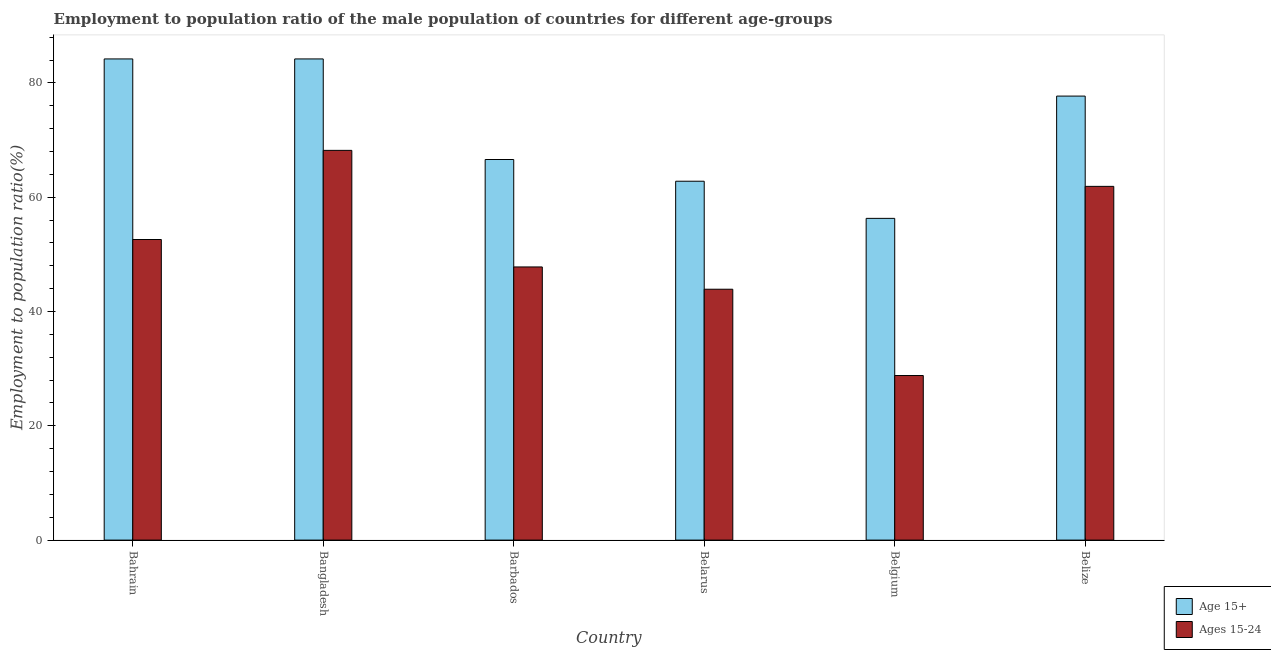How many groups of bars are there?
Give a very brief answer. 6. Are the number of bars on each tick of the X-axis equal?
Provide a succinct answer. Yes. How many bars are there on the 1st tick from the left?
Offer a very short reply. 2. What is the label of the 5th group of bars from the left?
Keep it short and to the point. Belgium. What is the employment to population ratio(age 15-24) in Belarus?
Make the answer very short. 43.9. Across all countries, what is the maximum employment to population ratio(age 15-24)?
Give a very brief answer. 68.2. Across all countries, what is the minimum employment to population ratio(age 15-24)?
Your answer should be compact. 28.8. In which country was the employment to population ratio(age 15+) minimum?
Your answer should be compact. Belgium. What is the total employment to population ratio(age 15+) in the graph?
Offer a terse response. 431.8. What is the difference between the employment to population ratio(age 15-24) in Belgium and that in Belize?
Offer a very short reply. -33.1. What is the difference between the employment to population ratio(age 15+) in Bangladesh and the employment to population ratio(age 15-24) in Belarus?
Offer a very short reply. 40.3. What is the average employment to population ratio(age 15+) per country?
Your answer should be very brief. 71.97. What is the difference between the employment to population ratio(age 15+) and employment to population ratio(age 15-24) in Belgium?
Your answer should be very brief. 27.5. What is the ratio of the employment to population ratio(age 15+) in Belarus to that in Belgium?
Your answer should be compact. 1.12. Is the employment to population ratio(age 15+) in Bangladesh less than that in Belize?
Provide a succinct answer. No. What is the difference between the highest and the second highest employment to population ratio(age 15-24)?
Provide a succinct answer. 6.3. What is the difference between the highest and the lowest employment to population ratio(age 15-24)?
Ensure brevity in your answer.  39.4. In how many countries, is the employment to population ratio(age 15-24) greater than the average employment to population ratio(age 15-24) taken over all countries?
Your answer should be compact. 3. Is the sum of the employment to population ratio(age 15+) in Belgium and Belize greater than the maximum employment to population ratio(age 15-24) across all countries?
Offer a terse response. Yes. What does the 1st bar from the left in Bahrain represents?
Your answer should be compact. Age 15+. What does the 2nd bar from the right in Bangladesh represents?
Provide a short and direct response. Age 15+. Are all the bars in the graph horizontal?
Provide a short and direct response. No. How many countries are there in the graph?
Your answer should be very brief. 6. Are the values on the major ticks of Y-axis written in scientific E-notation?
Make the answer very short. No. Does the graph contain any zero values?
Ensure brevity in your answer.  No. Does the graph contain grids?
Give a very brief answer. No. How many legend labels are there?
Keep it short and to the point. 2. What is the title of the graph?
Provide a succinct answer. Employment to population ratio of the male population of countries for different age-groups. What is the Employment to population ratio(%) in Age 15+ in Bahrain?
Your answer should be compact. 84.2. What is the Employment to population ratio(%) in Ages 15-24 in Bahrain?
Provide a short and direct response. 52.6. What is the Employment to population ratio(%) in Age 15+ in Bangladesh?
Your answer should be very brief. 84.2. What is the Employment to population ratio(%) in Ages 15-24 in Bangladesh?
Provide a short and direct response. 68.2. What is the Employment to population ratio(%) of Age 15+ in Barbados?
Offer a very short reply. 66.6. What is the Employment to population ratio(%) in Ages 15-24 in Barbados?
Your answer should be very brief. 47.8. What is the Employment to population ratio(%) of Age 15+ in Belarus?
Your answer should be compact. 62.8. What is the Employment to population ratio(%) of Ages 15-24 in Belarus?
Ensure brevity in your answer.  43.9. What is the Employment to population ratio(%) of Age 15+ in Belgium?
Offer a very short reply. 56.3. What is the Employment to population ratio(%) in Ages 15-24 in Belgium?
Give a very brief answer. 28.8. What is the Employment to population ratio(%) in Age 15+ in Belize?
Offer a terse response. 77.7. What is the Employment to population ratio(%) in Ages 15-24 in Belize?
Make the answer very short. 61.9. Across all countries, what is the maximum Employment to population ratio(%) of Age 15+?
Provide a succinct answer. 84.2. Across all countries, what is the maximum Employment to population ratio(%) in Ages 15-24?
Provide a succinct answer. 68.2. Across all countries, what is the minimum Employment to population ratio(%) in Age 15+?
Your answer should be compact. 56.3. Across all countries, what is the minimum Employment to population ratio(%) of Ages 15-24?
Your response must be concise. 28.8. What is the total Employment to population ratio(%) in Age 15+ in the graph?
Give a very brief answer. 431.8. What is the total Employment to population ratio(%) in Ages 15-24 in the graph?
Provide a short and direct response. 303.2. What is the difference between the Employment to population ratio(%) in Age 15+ in Bahrain and that in Bangladesh?
Offer a terse response. 0. What is the difference between the Employment to population ratio(%) of Ages 15-24 in Bahrain and that in Bangladesh?
Your response must be concise. -15.6. What is the difference between the Employment to population ratio(%) in Ages 15-24 in Bahrain and that in Barbados?
Give a very brief answer. 4.8. What is the difference between the Employment to population ratio(%) in Age 15+ in Bahrain and that in Belarus?
Your answer should be very brief. 21.4. What is the difference between the Employment to population ratio(%) of Age 15+ in Bahrain and that in Belgium?
Make the answer very short. 27.9. What is the difference between the Employment to population ratio(%) in Ages 15-24 in Bahrain and that in Belgium?
Give a very brief answer. 23.8. What is the difference between the Employment to population ratio(%) of Ages 15-24 in Bahrain and that in Belize?
Offer a terse response. -9.3. What is the difference between the Employment to population ratio(%) in Ages 15-24 in Bangladesh and that in Barbados?
Ensure brevity in your answer.  20.4. What is the difference between the Employment to population ratio(%) of Age 15+ in Bangladesh and that in Belarus?
Provide a succinct answer. 21.4. What is the difference between the Employment to population ratio(%) of Ages 15-24 in Bangladesh and that in Belarus?
Offer a very short reply. 24.3. What is the difference between the Employment to population ratio(%) of Age 15+ in Bangladesh and that in Belgium?
Provide a succinct answer. 27.9. What is the difference between the Employment to population ratio(%) of Ages 15-24 in Bangladesh and that in Belgium?
Provide a short and direct response. 39.4. What is the difference between the Employment to population ratio(%) in Age 15+ in Bangladesh and that in Belize?
Your answer should be very brief. 6.5. What is the difference between the Employment to population ratio(%) of Ages 15-24 in Barbados and that in Belize?
Your answer should be very brief. -14.1. What is the difference between the Employment to population ratio(%) of Age 15+ in Belarus and that in Belgium?
Make the answer very short. 6.5. What is the difference between the Employment to population ratio(%) of Age 15+ in Belarus and that in Belize?
Your answer should be very brief. -14.9. What is the difference between the Employment to population ratio(%) in Ages 15-24 in Belarus and that in Belize?
Keep it short and to the point. -18. What is the difference between the Employment to population ratio(%) of Age 15+ in Belgium and that in Belize?
Offer a very short reply. -21.4. What is the difference between the Employment to population ratio(%) in Ages 15-24 in Belgium and that in Belize?
Provide a short and direct response. -33.1. What is the difference between the Employment to population ratio(%) of Age 15+ in Bahrain and the Employment to population ratio(%) of Ages 15-24 in Bangladesh?
Your answer should be compact. 16. What is the difference between the Employment to population ratio(%) of Age 15+ in Bahrain and the Employment to population ratio(%) of Ages 15-24 in Barbados?
Your response must be concise. 36.4. What is the difference between the Employment to population ratio(%) in Age 15+ in Bahrain and the Employment to population ratio(%) in Ages 15-24 in Belarus?
Offer a very short reply. 40.3. What is the difference between the Employment to population ratio(%) of Age 15+ in Bahrain and the Employment to population ratio(%) of Ages 15-24 in Belgium?
Offer a terse response. 55.4. What is the difference between the Employment to population ratio(%) of Age 15+ in Bahrain and the Employment to population ratio(%) of Ages 15-24 in Belize?
Your response must be concise. 22.3. What is the difference between the Employment to population ratio(%) of Age 15+ in Bangladesh and the Employment to population ratio(%) of Ages 15-24 in Barbados?
Provide a succinct answer. 36.4. What is the difference between the Employment to population ratio(%) in Age 15+ in Bangladesh and the Employment to population ratio(%) in Ages 15-24 in Belarus?
Your response must be concise. 40.3. What is the difference between the Employment to population ratio(%) in Age 15+ in Bangladesh and the Employment to population ratio(%) in Ages 15-24 in Belgium?
Provide a succinct answer. 55.4. What is the difference between the Employment to population ratio(%) in Age 15+ in Bangladesh and the Employment to population ratio(%) in Ages 15-24 in Belize?
Provide a short and direct response. 22.3. What is the difference between the Employment to population ratio(%) of Age 15+ in Barbados and the Employment to population ratio(%) of Ages 15-24 in Belarus?
Offer a terse response. 22.7. What is the difference between the Employment to population ratio(%) of Age 15+ in Barbados and the Employment to population ratio(%) of Ages 15-24 in Belgium?
Make the answer very short. 37.8. What is the difference between the Employment to population ratio(%) in Age 15+ in Barbados and the Employment to population ratio(%) in Ages 15-24 in Belize?
Offer a very short reply. 4.7. What is the difference between the Employment to population ratio(%) of Age 15+ in Belarus and the Employment to population ratio(%) of Ages 15-24 in Belize?
Provide a succinct answer. 0.9. What is the difference between the Employment to population ratio(%) in Age 15+ in Belgium and the Employment to population ratio(%) in Ages 15-24 in Belize?
Your answer should be compact. -5.6. What is the average Employment to population ratio(%) in Age 15+ per country?
Your answer should be compact. 71.97. What is the average Employment to population ratio(%) in Ages 15-24 per country?
Make the answer very short. 50.53. What is the difference between the Employment to population ratio(%) of Age 15+ and Employment to population ratio(%) of Ages 15-24 in Bahrain?
Your answer should be compact. 31.6. What is the difference between the Employment to population ratio(%) in Age 15+ and Employment to population ratio(%) in Ages 15-24 in Bangladesh?
Make the answer very short. 16. What is the difference between the Employment to population ratio(%) in Age 15+ and Employment to population ratio(%) in Ages 15-24 in Belarus?
Your response must be concise. 18.9. What is the ratio of the Employment to population ratio(%) in Age 15+ in Bahrain to that in Bangladesh?
Your answer should be compact. 1. What is the ratio of the Employment to population ratio(%) in Ages 15-24 in Bahrain to that in Bangladesh?
Provide a short and direct response. 0.77. What is the ratio of the Employment to population ratio(%) of Age 15+ in Bahrain to that in Barbados?
Ensure brevity in your answer.  1.26. What is the ratio of the Employment to population ratio(%) in Ages 15-24 in Bahrain to that in Barbados?
Provide a short and direct response. 1.1. What is the ratio of the Employment to population ratio(%) of Age 15+ in Bahrain to that in Belarus?
Provide a succinct answer. 1.34. What is the ratio of the Employment to population ratio(%) in Ages 15-24 in Bahrain to that in Belarus?
Your response must be concise. 1.2. What is the ratio of the Employment to population ratio(%) in Age 15+ in Bahrain to that in Belgium?
Keep it short and to the point. 1.5. What is the ratio of the Employment to population ratio(%) in Ages 15-24 in Bahrain to that in Belgium?
Offer a terse response. 1.83. What is the ratio of the Employment to population ratio(%) in Age 15+ in Bahrain to that in Belize?
Offer a very short reply. 1.08. What is the ratio of the Employment to population ratio(%) of Ages 15-24 in Bahrain to that in Belize?
Ensure brevity in your answer.  0.85. What is the ratio of the Employment to population ratio(%) of Age 15+ in Bangladesh to that in Barbados?
Provide a succinct answer. 1.26. What is the ratio of the Employment to population ratio(%) of Ages 15-24 in Bangladesh to that in Barbados?
Your response must be concise. 1.43. What is the ratio of the Employment to population ratio(%) of Age 15+ in Bangladesh to that in Belarus?
Make the answer very short. 1.34. What is the ratio of the Employment to population ratio(%) of Ages 15-24 in Bangladesh to that in Belarus?
Give a very brief answer. 1.55. What is the ratio of the Employment to population ratio(%) of Age 15+ in Bangladesh to that in Belgium?
Provide a short and direct response. 1.5. What is the ratio of the Employment to population ratio(%) of Ages 15-24 in Bangladesh to that in Belgium?
Give a very brief answer. 2.37. What is the ratio of the Employment to population ratio(%) of Age 15+ in Bangladesh to that in Belize?
Offer a terse response. 1.08. What is the ratio of the Employment to population ratio(%) in Ages 15-24 in Bangladesh to that in Belize?
Your response must be concise. 1.1. What is the ratio of the Employment to population ratio(%) in Age 15+ in Barbados to that in Belarus?
Provide a short and direct response. 1.06. What is the ratio of the Employment to population ratio(%) in Ages 15-24 in Barbados to that in Belarus?
Make the answer very short. 1.09. What is the ratio of the Employment to population ratio(%) of Age 15+ in Barbados to that in Belgium?
Ensure brevity in your answer.  1.18. What is the ratio of the Employment to population ratio(%) of Ages 15-24 in Barbados to that in Belgium?
Provide a succinct answer. 1.66. What is the ratio of the Employment to population ratio(%) in Age 15+ in Barbados to that in Belize?
Make the answer very short. 0.86. What is the ratio of the Employment to population ratio(%) in Ages 15-24 in Barbados to that in Belize?
Give a very brief answer. 0.77. What is the ratio of the Employment to population ratio(%) in Age 15+ in Belarus to that in Belgium?
Provide a short and direct response. 1.12. What is the ratio of the Employment to population ratio(%) in Ages 15-24 in Belarus to that in Belgium?
Ensure brevity in your answer.  1.52. What is the ratio of the Employment to population ratio(%) of Age 15+ in Belarus to that in Belize?
Offer a terse response. 0.81. What is the ratio of the Employment to population ratio(%) in Ages 15-24 in Belarus to that in Belize?
Provide a short and direct response. 0.71. What is the ratio of the Employment to population ratio(%) of Age 15+ in Belgium to that in Belize?
Your answer should be very brief. 0.72. What is the ratio of the Employment to population ratio(%) of Ages 15-24 in Belgium to that in Belize?
Make the answer very short. 0.47. What is the difference between the highest and the second highest Employment to population ratio(%) of Age 15+?
Offer a very short reply. 0. What is the difference between the highest and the second highest Employment to population ratio(%) in Ages 15-24?
Keep it short and to the point. 6.3. What is the difference between the highest and the lowest Employment to population ratio(%) of Age 15+?
Keep it short and to the point. 27.9. What is the difference between the highest and the lowest Employment to population ratio(%) of Ages 15-24?
Make the answer very short. 39.4. 